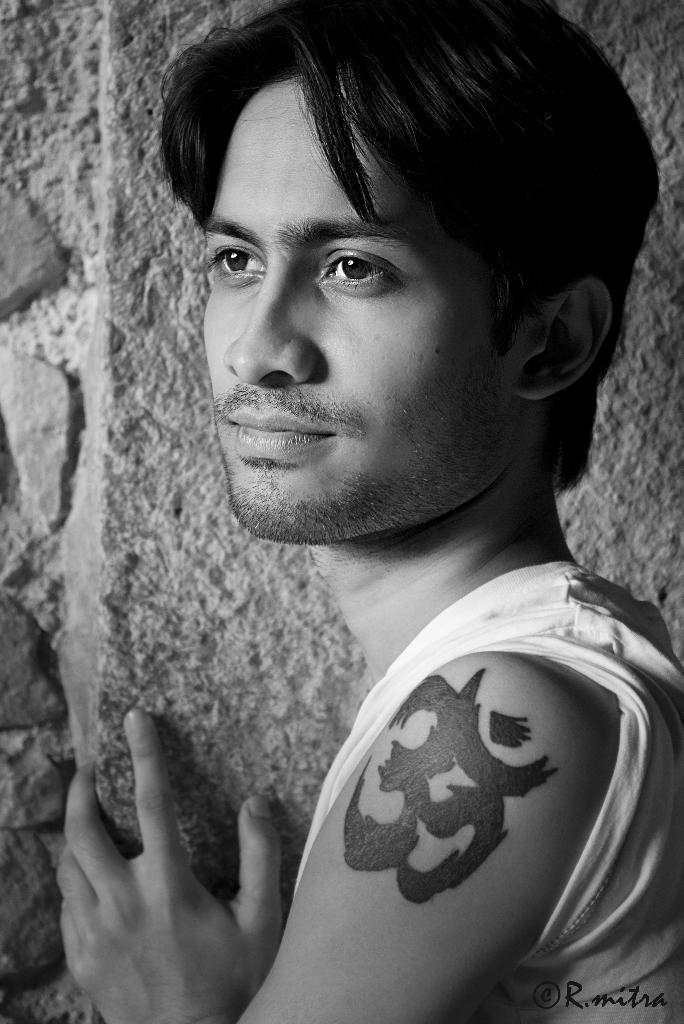Could you give a brief overview of what you see in this image? In this image, we can see a man with tattoo and in the background, there is a wall. 